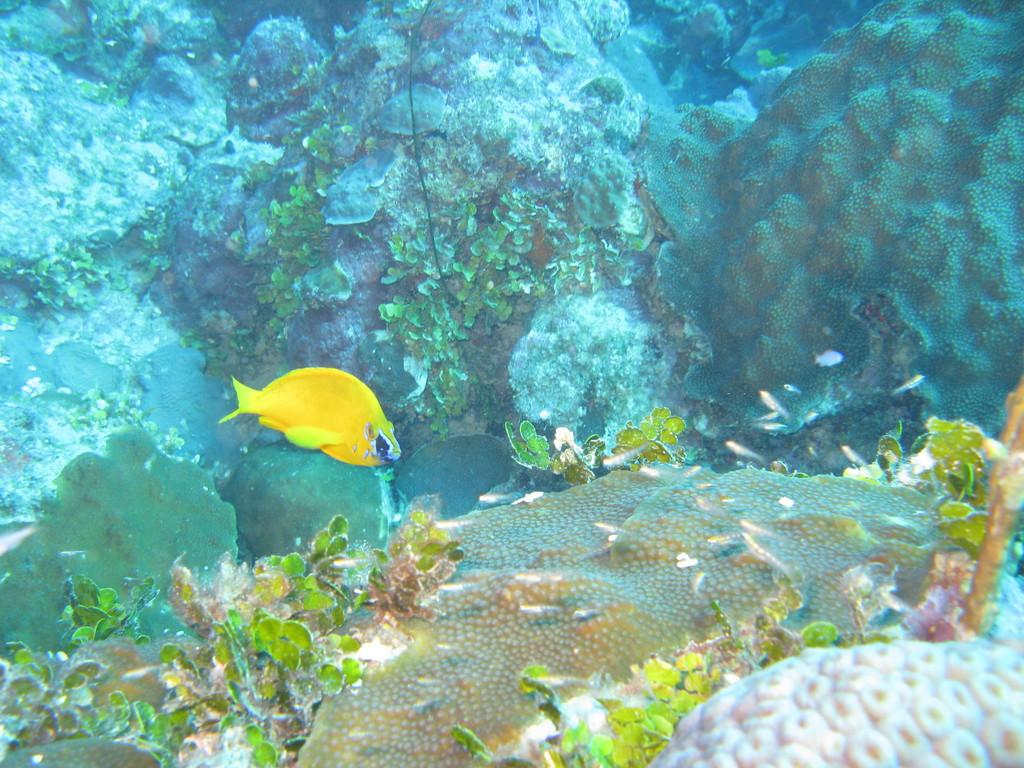What type of animal is in the image? There is a yellow fish in the image. What else can be seen in the water besides the fish? There are plants and rocks in the water. What type of horn can be seen on the fish in the image? There is no horn present on the fish in the image. 